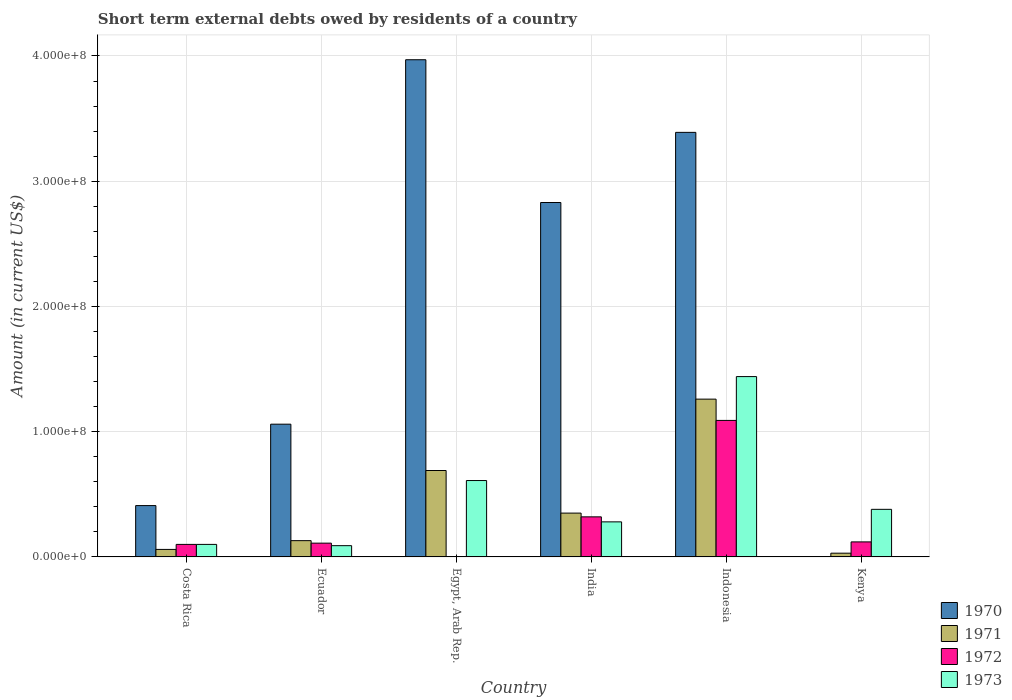Are the number of bars on each tick of the X-axis equal?
Your response must be concise. No. How many bars are there on the 4th tick from the right?
Offer a terse response. 3. What is the label of the 6th group of bars from the left?
Provide a short and direct response. Kenya. In how many cases, is the number of bars for a given country not equal to the number of legend labels?
Give a very brief answer. 2. What is the amount of short-term external debts owed by residents in 1970 in Costa Rica?
Provide a succinct answer. 4.10e+07. Across all countries, what is the maximum amount of short-term external debts owed by residents in 1970?
Provide a short and direct response. 3.97e+08. What is the total amount of short-term external debts owed by residents in 1971 in the graph?
Give a very brief answer. 2.52e+08. What is the difference between the amount of short-term external debts owed by residents in 1971 in Ecuador and that in Egypt, Arab Rep.?
Provide a succinct answer. -5.60e+07. What is the difference between the amount of short-term external debts owed by residents in 1972 in Costa Rica and the amount of short-term external debts owed by residents in 1973 in India?
Your answer should be very brief. -1.80e+07. What is the average amount of short-term external debts owed by residents in 1973 per country?
Your answer should be compact. 4.83e+07. What is the difference between the amount of short-term external debts owed by residents of/in 1970 and amount of short-term external debts owed by residents of/in 1972 in India?
Offer a terse response. 2.51e+08. What is the ratio of the amount of short-term external debts owed by residents in 1972 in Ecuador to that in India?
Your answer should be very brief. 0.34. What is the difference between the highest and the second highest amount of short-term external debts owed by residents in 1970?
Ensure brevity in your answer.  1.14e+08. What is the difference between the highest and the lowest amount of short-term external debts owed by residents in 1972?
Provide a succinct answer. 1.09e+08. Is it the case that in every country, the sum of the amount of short-term external debts owed by residents in 1973 and amount of short-term external debts owed by residents in 1972 is greater than the sum of amount of short-term external debts owed by residents in 1970 and amount of short-term external debts owed by residents in 1971?
Offer a very short reply. No. Is it the case that in every country, the sum of the amount of short-term external debts owed by residents in 1971 and amount of short-term external debts owed by residents in 1970 is greater than the amount of short-term external debts owed by residents in 1972?
Your response must be concise. No. How many bars are there?
Give a very brief answer. 22. Are all the bars in the graph horizontal?
Keep it short and to the point. No. Are the values on the major ticks of Y-axis written in scientific E-notation?
Make the answer very short. Yes. Does the graph contain any zero values?
Your answer should be compact. Yes. Does the graph contain grids?
Provide a short and direct response. Yes. Where does the legend appear in the graph?
Your response must be concise. Bottom right. What is the title of the graph?
Ensure brevity in your answer.  Short term external debts owed by residents of a country. Does "1994" appear as one of the legend labels in the graph?
Offer a very short reply. No. What is the label or title of the Y-axis?
Ensure brevity in your answer.  Amount (in current US$). What is the Amount (in current US$) of 1970 in Costa Rica?
Offer a very short reply. 4.10e+07. What is the Amount (in current US$) in 1973 in Costa Rica?
Offer a terse response. 1.00e+07. What is the Amount (in current US$) in 1970 in Ecuador?
Ensure brevity in your answer.  1.06e+08. What is the Amount (in current US$) of 1971 in Ecuador?
Provide a short and direct response. 1.30e+07. What is the Amount (in current US$) of 1972 in Ecuador?
Provide a short and direct response. 1.10e+07. What is the Amount (in current US$) in 1973 in Ecuador?
Make the answer very short. 9.00e+06. What is the Amount (in current US$) of 1970 in Egypt, Arab Rep.?
Provide a succinct answer. 3.97e+08. What is the Amount (in current US$) of 1971 in Egypt, Arab Rep.?
Offer a terse response. 6.90e+07. What is the Amount (in current US$) of 1973 in Egypt, Arab Rep.?
Provide a short and direct response. 6.10e+07. What is the Amount (in current US$) in 1970 in India?
Provide a short and direct response. 2.83e+08. What is the Amount (in current US$) of 1971 in India?
Offer a terse response. 3.50e+07. What is the Amount (in current US$) in 1972 in India?
Give a very brief answer. 3.20e+07. What is the Amount (in current US$) of 1973 in India?
Keep it short and to the point. 2.80e+07. What is the Amount (in current US$) in 1970 in Indonesia?
Offer a very short reply. 3.39e+08. What is the Amount (in current US$) in 1971 in Indonesia?
Provide a succinct answer. 1.26e+08. What is the Amount (in current US$) of 1972 in Indonesia?
Offer a terse response. 1.09e+08. What is the Amount (in current US$) of 1973 in Indonesia?
Provide a short and direct response. 1.44e+08. What is the Amount (in current US$) of 1971 in Kenya?
Keep it short and to the point. 3.00e+06. What is the Amount (in current US$) in 1972 in Kenya?
Give a very brief answer. 1.20e+07. What is the Amount (in current US$) of 1973 in Kenya?
Offer a terse response. 3.80e+07. Across all countries, what is the maximum Amount (in current US$) in 1970?
Provide a short and direct response. 3.97e+08. Across all countries, what is the maximum Amount (in current US$) of 1971?
Give a very brief answer. 1.26e+08. Across all countries, what is the maximum Amount (in current US$) in 1972?
Make the answer very short. 1.09e+08. Across all countries, what is the maximum Amount (in current US$) in 1973?
Your answer should be compact. 1.44e+08. Across all countries, what is the minimum Amount (in current US$) of 1971?
Your answer should be very brief. 3.00e+06. Across all countries, what is the minimum Amount (in current US$) in 1973?
Make the answer very short. 9.00e+06. What is the total Amount (in current US$) in 1970 in the graph?
Give a very brief answer. 1.17e+09. What is the total Amount (in current US$) of 1971 in the graph?
Keep it short and to the point. 2.52e+08. What is the total Amount (in current US$) in 1972 in the graph?
Make the answer very short. 1.74e+08. What is the total Amount (in current US$) in 1973 in the graph?
Provide a short and direct response. 2.90e+08. What is the difference between the Amount (in current US$) in 1970 in Costa Rica and that in Ecuador?
Give a very brief answer. -6.50e+07. What is the difference between the Amount (in current US$) in 1971 in Costa Rica and that in Ecuador?
Ensure brevity in your answer.  -7.00e+06. What is the difference between the Amount (in current US$) of 1973 in Costa Rica and that in Ecuador?
Your answer should be compact. 1.00e+06. What is the difference between the Amount (in current US$) in 1970 in Costa Rica and that in Egypt, Arab Rep.?
Provide a succinct answer. -3.56e+08. What is the difference between the Amount (in current US$) of 1971 in Costa Rica and that in Egypt, Arab Rep.?
Your response must be concise. -6.30e+07. What is the difference between the Amount (in current US$) in 1973 in Costa Rica and that in Egypt, Arab Rep.?
Provide a short and direct response. -5.10e+07. What is the difference between the Amount (in current US$) in 1970 in Costa Rica and that in India?
Offer a terse response. -2.42e+08. What is the difference between the Amount (in current US$) in 1971 in Costa Rica and that in India?
Give a very brief answer. -2.90e+07. What is the difference between the Amount (in current US$) of 1972 in Costa Rica and that in India?
Your answer should be compact. -2.20e+07. What is the difference between the Amount (in current US$) of 1973 in Costa Rica and that in India?
Your response must be concise. -1.80e+07. What is the difference between the Amount (in current US$) of 1970 in Costa Rica and that in Indonesia?
Your response must be concise. -2.98e+08. What is the difference between the Amount (in current US$) of 1971 in Costa Rica and that in Indonesia?
Offer a terse response. -1.20e+08. What is the difference between the Amount (in current US$) of 1972 in Costa Rica and that in Indonesia?
Your answer should be compact. -9.90e+07. What is the difference between the Amount (in current US$) in 1973 in Costa Rica and that in Indonesia?
Your answer should be compact. -1.34e+08. What is the difference between the Amount (in current US$) of 1971 in Costa Rica and that in Kenya?
Your response must be concise. 3.00e+06. What is the difference between the Amount (in current US$) in 1973 in Costa Rica and that in Kenya?
Make the answer very short. -2.80e+07. What is the difference between the Amount (in current US$) in 1970 in Ecuador and that in Egypt, Arab Rep.?
Provide a succinct answer. -2.91e+08. What is the difference between the Amount (in current US$) in 1971 in Ecuador and that in Egypt, Arab Rep.?
Make the answer very short. -5.60e+07. What is the difference between the Amount (in current US$) of 1973 in Ecuador and that in Egypt, Arab Rep.?
Keep it short and to the point. -5.20e+07. What is the difference between the Amount (in current US$) of 1970 in Ecuador and that in India?
Make the answer very short. -1.77e+08. What is the difference between the Amount (in current US$) of 1971 in Ecuador and that in India?
Ensure brevity in your answer.  -2.20e+07. What is the difference between the Amount (in current US$) in 1972 in Ecuador and that in India?
Your response must be concise. -2.10e+07. What is the difference between the Amount (in current US$) in 1973 in Ecuador and that in India?
Your response must be concise. -1.90e+07. What is the difference between the Amount (in current US$) in 1970 in Ecuador and that in Indonesia?
Offer a very short reply. -2.33e+08. What is the difference between the Amount (in current US$) in 1971 in Ecuador and that in Indonesia?
Your response must be concise. -1.13e+08. What is the difference between the Amount (in current US$) of 1972 in Ecuador and that in Indonesia?
Give a very brief answer. -9.80e+07. What is the difference between the Amount (in current US$) in 1973 in Ecuador and that in Indonesia?
Provide a short and direct response. -1.35e+08. What is the difference between the Amount (in current US$) in 1973 in Ecuador and that in Kenya?
Provide a short and direct response. -2.90e+07. What is the difference between the Amount (in current US$) of 1970 in Egypt, Arab Rep. and that in India?
Give a very brief answer. 1.14e+08. What is the difference between the Amount (in current US$) in 1971 in Egypt, Arab Rep. and that in India?
Keep it short and to the point. 3.40e+07. What is the difference between the Amount (in current US$) of 1973 in Egypt, Arab Rep. and that in India?
Provide a succinct answer. 3.30e+07. What is the difference between the Amount (in current US$) in 1970 in Egypt, Arab Rep. and that in Indonesia?
Your answer should be very brief. 5.80e+07. What is the difference between the Amount (in current US$) of 1971 in Egypt, Arab Rep. and that in Indonesia?
Ensure brevity in your answer.  -5.70e+07. What is the difference between the Amount (in current US$) of 1973 in Egypt, Arab Rep. and that in Indonesia?
Your answer should be very brief. -8.30e+07. What is the difference between the Amount (in current US$) of 1971 in Egypt, Arab Rep. and that in Kenya?
Ensure brevity in your answer.  6.60e+07. What is the difference between the Amount (in current US$) of 1973 in Egypt, Arab Rep. and that in Kenya?
Ensure brevity in your answer.  2.30e+07. What is the difference between the Amount (in current US$) in 1970 in India and that in Indonesia?
Give a very brief answer. -5.60e+07. What is the difference between the Amount (in current US$) in 1971 in India and that in Indonesia?
Make the answer very short. -9.10e+07. What is the difference between the Amount (in current US$) of 1972 in India and that in Indonesia?
Ensure brevity in your answer.  -7.70e+07. What is the difference between the Amount (in current US$) in 1973 in India and that in Indonesia?
Your answer should be compact. -1.16e+08. What is the difference between the Amount (in current US$) of 1971 in India and that in Kenya?
Your answer should be compact. 3.20e+07. What is the difference between the Amount (in current US$) of 1973 in India and that in Kenya?
Ensure brevity in your answer.  -1.00e+07. What is the difference between the Amount (in current US$) of 1971 in Indonesia and that in Kenya?
Your answer should be very brief. 1.23e+08. What is the difference between the Amount (in current US$) in 1972 in Indonesia and that in Kenya?
Provide a succinct answer. 9.70e+07. What is the difference between the Amount (in current US$) of 1973 in Indonesia and that in Kenya?
Your response must be concise. 1.06e+08. What is the difference between the Amount (in current US$) of 1970 in Costa Rica and the Amount (in current US$) of 1971 in Ecuador?
Your response must be concise. 2.80e+07. What is the difference between the Amount (in current US$) of 1970 in Costa Rica and the Amount (in current US$) of 1972 in Ecuador?
Give a very brief answer. 3.00e+07. What is the difference between the Amount (in current US$) in 1970 in Costa Rica and the Amount (in current US$) in 1973 in Ecuador?
Your answer should be very brief. 3.20e+07. What is the difference between the Amount (in current US$) in 1971 in Costa Rica and the Amount (in current US$) in 1972 in Ecuador?
Offer a terse response. -5.00e+06. What is the difference between the Amount (in current US$) of 1972 in Costa Rica and the Amount (in current US$) of 1973 in Ecuador?
Give a very brief answer. 1.00e+06. What is the difference between the Amount (in current US$) of 1970 in Costa Rica and the Amount (in current US$) of 1971 in Egypt, Arab Rep.?
Your response must be concise. -2.80e+07. What is the difference between the Amount (in current US$) in 1970 in Costa Rica and the Amount (in current US$) in 1973 in Egypt, Arab Rep.?
Ensure brevity in your answer.  -2.00e+07. What is the difference between the Amount (in current US$) in 1971 in Costa Rica and the Amount (in current US$) in 1973 in Egypt, Arab Rep.?
Keep it short and to the point. -5.50e+07. What is the difference between the Amount (in current US$) of 1972 in Costa Rica and the Amount (in current US$) of 1973 in Egypt, Arab Rep.?
Offer a very short reply. -5.10e+07. What is the difference between the Amount (in current US$) of 1970 in Costa Rica and the Amount (in current US$) of 1971 in India?
Offer a terse response. 6.00e+06. What is the difference between the Amount (in current US$) of 1970 in Costa Rica and the Amount (in current US$) of 1972 in India?
Offer a terse response. 9.00e+06. What is the difference between the Amount (in current US$) of 1970 in Costa Rica and the Amount (in current US$) of 1973 in India?
Provide a short and direct response. 1.30e+07. What is the difference between the Amount (in current US$) of 1971 in Costa Rica and the Amount (in current US$) of 1972 in India?
Give a very brief answer. -2.60e+07. What is the difference between the Amount (in current US$) in 1971 in Costa Rica and the Amount (in current US$) in 1973 in India?
Make the answer very short. -2.20e+07. What is the difference between the Amount (in current US$) in 1972 in Costa Rica and the Amount (in current US$) in 1973 in India?
Offer a terse response. -1.80e+07. What is the difference between the Amount (in current US$) in 1970 in Costa Rica and the Amount (in current US$) in 1971 in Indonesia?
Offer a terse response. -8.50e+07. What is the difference between the Amount (in current US$) of 1970 in Costa Rica and the Amount (in current US$) of 1972 in Indonesia?
Make the answer very short. -6.80e+07. What is the difference between the Amount (in current US$) in 1970 in Costa Rica and the Amount (in current US$) in 1973 in Indonesia?
Your response must be concise. -1.03e+08. What is the difference between the Amount (in current US$) of 1971 in Costa Rica and the Amount (in current US$) of 1972 in Indonesia?
Keep it short and to the point. -1.03e+08. What is the difference between the Amount (in current US$) in 1971 in Costa Rica and the Amount (in current US$) in 1973 in Indonesia?
Ensure brevity in your answer.  -1.38e+08. What is the difference between the Amount (in current US$) in 1972 in Costa Rica and the Amount (in current US$) in 1973 in Indonesia?
Ensure brevity in your answer.  -1.34e+08. What is the difference between the Amount (in current US$) in 1970 in Costa Rica and the Amount (in current US$) in 1971 in Kenya?
Offer a terse response. 3.80e+07. What is the difference between the Amount (in current US$) of 1970 in Costa Rica and the Amount (in current US$) of 1972 in Kenya?
Your answer should be compact. 2.90e+07. What is the difference between the Amount (in current US$) in 1970 in Costa Rica and the Amount (in current US$) in 1973 in Kenya?
Make the answer very short. 3.00e+06. What is the difference between the Amount (in current US$) of 1971 in Costa Rica and the Amount (in current US$) of 1972 in Kenya?
Provide a short and direct response. -6.00e+06. What is the difference between the Amount (in current US$) in 1971 in Costa Rica and the Amount (in current US$) in 1973 in Kenya?
Give a very brief answer. -3.20e+07. What is the difference between the Amount (in current US$) of 1972 in Costa Rica and the Amount (in current US$) of 1973 in Kenya?
Provide a short and direct response. -2.80e+07. What is the difference between the Amount (in current US$) of 1970 in Ecuador and the Amount (in current US$) of 1971 in Egypt, Arab Rep.?
Keep it short and to the point. 3.70e+07. What is the difference between the Amount (in current US$) in 1970 in Ecuador and the Amount (in current US$) in 1973 in Egypt, Arab Rep.?
Your answer should be compact. 4.50e+07. What is the difference between the Amount (in current US$) in 1971 in Ecuador and the Amount (in current US$) in 1973 in Egypt, Arab Rep.?
Make the answer very short. -4.80e+07. What is the difference between the Amount (in current US$) of 1972 in Ecuador and the Amount (in current US$) of 1973 in Egypt, Arab Rep.?
Your answer should be very brief. -5.00e+07. What is the difference between the Amount (in current US$) of 1970 in Ecuador and the Amount (in current US$) of 1971 in India?
Provide a short and direct response. 7.10e+07. What is the difference between the Amount (in current US$) in 1970 in Ecuador and the Amount (in current US$) in 1972 in India?
Make the answer very short. 7.40e+07. What is the difference between the Amount (in current US$) of 1970 in Ecuador and the Amount (in current US$) of 1973 in India?
Offer a very short reply. 7.80e+07. What is the difference between the Amount (in current US$) in 1971 in Ecuador and the Amount (in current US$) in 1972 in India?
Make the answer very short. -1.90e+07. What is the difference between the Amount (in current US$) in 1971 in Ecuador and the Amount (in current US$) in 1973 in India?
Your response must be concise. -1.50e+07. What is the difference between the Amount (in current US$) of 1972 in Ecuador and the Amount (in current US$) of 1973 in India?
Provide a succinct answer. -1.70e+07. What is the difference between the Amount (in current US$) of 1970 in Ecuador and the Amount (in current US$) of 1971 in Indonesia?
Offer a terse response. -2.00e+07. What is the difference between the Amount (in current US$) in 1970 in Ecuador and the Amount (in current US$) in 1972 in Indonesia?
Provide a short and direct response. -3.00e+06. What is the difference between the Amount (in current US$) in 1970 in Ecuador and the Amount (in current US$) in 1973 in Indonesia?
Provide a succinct answer. -3.80e+07. What is the difference between the Amount (in current US$) in 1971 in Ecuador and the Amount (in current US$) in 1972 in Indonesia?
Offer a very short reply. -9.60e+07. What is the difference between the Amount (in current US$) of 1971 in Ecuador and the Amount (in current US$) of 1973 in Indonesia?
Offer a very short reply. -1.31e+08. What is the difference between the Amount (in current US$) of 1972 in Ecuador and the Amount (in current US$) of 1973 in Indonesia?
Offer a terse response. -1.33e+08. What is the difference between the Amount (in current US$) in 1970 in Ecuador and the Amount (in current US$) in 1971 in Kenya?
Keep it short and to the point. 1.03e+08. What is the difference between the Amount (in current US$) of 1970 in Ecuador and the Amount (in current US$) of 1972 in Kenya?
Your response must be concise. 9.40e+07. What is the difference between the Amount (in current US$) of 1970 in Ecuador and the Amount (in current US$) of 1973 in Kenya?
Make the answer very short. 6.80e+07. What is the difference between the Amount (in current US$) in 1971 in Ecuador and the Amount (in current US$) in 1972 in Kenya?
Your answer should be very brief. 1.00e+06. What is the difference between the Amount (in current US$) of 1971 in Ecuador and the Amount (in current US$) of 1973 in Kenya?
Provide a succinct answer. -2.50e+07. What is the difference between the Amount (in current US$) in 1972 in Ecuador and the Amount (in current US$) in 1973 in Kenya?
Your answer should be very brief. -2.70e+07. What is the difference between the Amount (in current US$) in 1970 in Egypt, Arab Rep. and the Amount (in current US$) in 1971 in India?
Ensure brevity in your answer.  3.62e+08. What is the difference between the Amount (in current US$) of 1970 in Egypt, Arab Rep. and the Amount (in current US$) of 1972 in India?
Make the answer very short. 3.65e+08. What is the difference between the Amount (in current US$) in 1970 in Egypt, Arab Rep. and the Amount (in current US$) in 1973 in India?
Ensure brevity in your answer.  3.69e+08. What is the difference between the Amount (in current US$) of 1971 in Egypt, Arab Rep. and the Amount (in current US$) of 1972 in India?
Ensure brevity in your answer.  3.70e+07. What is the difference between the Amount (in current US$) of 1971 in Egypt, Arab Rep. and the Amount (in current US$) of 1973 in India?
Offer a very short reply. 4.10e+07. What is the difference between the Amount (in current US$) of 1970 in Egypt, Arab Rep. and the Amount (in current US$) of 1971 in Indonesia?
Offer a very short reply. 2.71e+08. What is the difference between the Amount (in current US$) of 1970 in Egypt, Arab Rep. and the Amount (in current US$) of 1972 in Indonesia?
Provide a succinct answer. 2.88e+08. What is the difference between the Amount (in current US$) in 1970 in Egypt, Arab Rep. and the Amount (in current US$) in 1973 in Indonesia?
Your response must be concise. 2.53e+08. What is the difference between the Amount (in current US$) in 1971 in Egypt, Arab Rep. and the Amount (in current US$) in 1972 in Indonesia?
Give a very brief answer. -4.00e+07. What is the difference between the Amount (in current US$) of 1971 in Egypt, Arab Rep. and the Amount (in current US$) of 1973 in Indonesia?
Your answer should be compact. -7.50e+07. What is the difference between the Amount (in current US$) of 1970 in Egypt, Arab Rep. and the Amount (in current US$) of 1971 in Kenya?
Give a very brief answer. 3.94e+08. What is the difference between the Amount (in current US$) of 1970 in Egypt, Arab Rep. and the Amount (in current US$) of 1972 in Kenya?
Offer a very short reply. 3.85e+08. What is the difference between the Amount (in current US$) of 1970 in Egypt, Arab Rep. and the Amount (in current US$) of 1973 in Kenya?
Provide a short and direct response. 3.59e+08. What is the difference between the Amount (in current US$) of 1971 in Egypt, Arab Rep. and the Amount (in current US$) of 1972 in Kenya?
Provide a short and direct response. 5.70e+07. What is the difference between the Amount (in current US$) in 1971 in Egypt, Arab Rep. and the Amount (in current US$) in 1973 in Kenya?
Ensure brevity in your answer.  3.10e+07. What is the difference between the Amount (in current US$) in 1970 in India and the Amount (in current US$) in 1971 in Indonesia?
Your answer should be very brief. 1.57e+08. What is the difference between the Amount (in current US$) in 1970 in India and the Amount (in current US$) in 1972 in Indonesia?
Your answer should be very brief. 1.74e+08. What is the difference between the Amount (in current US$) of 1970 in India and the Amount (in current US$) of 1973 in Indonesia?
Your answer should be very brief. 1.39e+08. What is the difference between the Amount (in current US$) of 1971 in India and the Amount (in current US$) of 1972 in Indonesia?
Give a very brief answer. -7.40e+07. What is the difference between the Amount (in current US$) in 1971 in India and the Amount (in current US$) in 1973 in Indonesia?
Ensure brevity in your answer.  -1.09e+08. What is the difference between the Amount (in current US$) in 1972 in India and the Amount (in current US$) in 1973 in Indonesia?
Your answer should be compact. -1.12e+08. What is the difference between the Amount (in current US$) in 1970 in India and the Amount (in current US$) in 1971 in Kenya?
Offer a very short reply. 2.80e+08. What is the difference between the Amount (in current US$) of 1970 in India and the Amount (in current US$) of 1972 in Kenya?
Make the answer very short. 2.71e+08. What is the difference between the Amount (in current US$) of 1970 in India and the Amount (in current US$) of 1973 in Kenya?
Make the answer very short. 2.45e+08. What is the difference between the Amount (in current US$) of 1971 in India and the Amount (in current US$) of 1972 in Kenya?
Provide a succinct answer. 2.30e+07. What is the difference between the Amount (in current US$) of 1971 in India and the Amount (in current US$) of 1973 in Kenya?
Offer a very short reply. -3.00e+06. What is the difference between the Amount (in current US$) in 1972 in India and the Amount (in current US$) in 1973 in Kenya?
Provide a succinct answer. -6.00e+06. What is the difference between the Amount (in current US$) in 1970 in Indonesia and the Amount (in current US$) in 1971 in Kenya?
Provide a short and direct response. 3.36e+08. What is the difference between the Amount (in current US$) of 1970 in Indonesia and the Amount (in current US$) of 1972 in Kenya?
Keep it short and to the point. 3.27e+08. What is the difference between the Amount (in current US$) in 1970 in Indonesia and the Amount (in current US$) in 1973 in Kenya?
Ensure brevity in your answer.  3.01e+08. What is the difference between the Amount (in current US$) in 1971 in Indonesia and the Amount (in current US$) in 1972 in Kenya?
Make the answer very short. 1.14e+08. What is the difference between the Amount (in current US$) in 1971 in Indonesia and the Amount (in current US$) in 1973 in Kenya?
Ensure brevity in your answer.  8.80e+07. What is the difference between the Amount (in current US$) of 1972 in Indonesia and the Amount (in current US$) of 1973 in Kenya?
Ensure brevity in your answer.  7.10e+07. What is the average Amount (in current US$) of 1970 per country?
Keep it short and to the point. 1.94e+08. What is the average Amount (in current US$) in 1971 per country?
Keep it short and to the point. 4.20e+07. What is the average Amount (in current US$) in 1972 per country?
Your answer should be very brief. 2.90e+07. What is the average Amount (in current US$) in 1973 per country?
Your answer should be compact. 4.83e+07. What is the difference between the Amount (in current US$) of 1970 and Amount (in current US$) of 1971 in Costa Rica?
Make the answer very short. 3.50e+07. What is the difference between the Amount (in current US$) of 1970 and Amount (in current US$) of 1972 in Costa Rica?
Ensure brevity in your answer.  3.10e+07. What is the difference between the Amount (in current US$) in 1970 and Amount (in current US$) in 1973 in Costa Rica?
Offer a terse response. 3.10e+07. What is the difference between the Amount (in current US$) of 1972 and Amount (in current US$) of 1973 in Costa Rica?
Make the answer very short. 0. What is the difference between the Amount (in current US$) in 1970 and Amount (in current US$) in 1971 in Ecuador?
Offer a very short reply. 9.30e+07. What is the difference between the Amount (in current US$) of 1970 and Amount (in current US$) of 1972 in Ecuador?
Ensure brevity in your answer.  9.50e+07. What is the difference between the Amount (in current US$) of 1970 and Amount (in current US$) of 1973 in Ecuador?
Ensure brevity in your answer.  9.70e+07. What is the difference between the Amount (in current US$) in 1971 and Amount (in current US$) in 1972 in Ecuador?
Keep it short and to the point. 2.00e+06. What is the difference between the Amount (in current US$) of 1971 and Amount (in current US$) of 1973 in Ecuador?
Provide a short and direct response. 4.00e+06. What is the difference between the Amount (in current US$) in 1970 and Amount (in current US$) in 1971 in Egypt, Arab Rep.?
Make the answer very short. 3.28e+08. What is the difference between the Amount (in current US$) of 1970 and Amount (in current US$) of 1973 in Egypt, Arab Rep.?
Offer a terse response. 3.36e+08. What is the difference between the Amount (in current US$) in 1971 and Amount (in current US$) in 1973 in Egypt, Arab Rep.?
Your answer should be very brief. 8.00e+06. What is the difference between the Amount (in current US$) in 1970 and Amount (in current US$) in 1971 in India?
Your answer should be compact. 2.48e+08. What is the difference between the Amount (in current US$) of 1970 and Amount (in current US$) of 1972 in India?
Give a very brief answer. 2.51e+08. What is the difference between the Amount (in current US$) in 1970 and Amount (in current US$) in 1973 in India?
Offer a terse response. 2.55e+08. What is the difference between the Amount (in current US$) in 1971 and Amount (in current US$) in 1972 in India?
Your answer should be very brief. 3.00e+06. What is the difference between the Amount (in current US$) in 1971 and Amount (in current US$) in 1973 in India?
Make the answer very short. 7.00e+06. What is the difference between the Amount (in current US$) of 1970 and Amount (in current US$) of 1971 in Indonesia?
Ensure brevity in your answer.  2.13e+08. What is the difference between the Amount (in current US$) of 1970 and Amount (in current US$) of 1972 in Indonesia?
Your answer should be compact. 2.30e+08. What is the difference between the Amount (in current US$) of 1970 and Amount (in current US$) of 1973 in Indonesia?
Offer a very short reply. 1.95e+08. What is the difference between the Amount (in current US$) of 1971 and Amount (in current US$) of 1972 in Indonesia?
Provide a short and direct response. 1.70e+07. What is the difference between the Amount (in current US$) of 1971 and Amount (in current US$) of 1973 in Indonesia?
Make the answer very short. -1.80e+07. What is the difference between the Amount (in current US$) of 1972 and Amount (in current US$) of 1973 in Indonesia?
Provide a succinct answer. -3.50e+07. What is the difference between the Amount (in current US$) in 1971 and Amount (in current US$) in 1972 in Kenya?
Provide a succinct answer. -9.00e+06. What is the difference between the Amount (in current US$) in 1971 and Amount (in current US$) in 1973 in Kenya?
Keep it short and to the point. -3.50e+07. What is the difference between the Amount (in current US$) in 1972 and Amount (in current US$) in 1973 in Kenya?
Your answer should be very brief. -2.60e+07. What is the ratio of the Amount (in current US$) of 1970 in Costa Rica to that in Ecuador?
Provide a short and direct response. 0.39. What is the ratio of the Amount (in current US$) of 1971 in Costa Rica to that in Ecuador?
Provide a succinct answer. 0.46. What is the ratio of the Amount (in current US$) in 1972 in Costa Rica to that in Ecuador?
Your answer should be very brief. 0.91. What is the ratio of the Amount (in current US$) of 1973 in Costa Rica to that in Ecuador?
Ensure brevity in your answer.  1.11. What is the ratio of the Amount (in current US$) of 1970 in Costa Rica to that in Egypt, Arab Rep.?
Your answer should be compact. 0.1. What is the ratio of the Amount (in current US$) in 1971 in Costa Rica to that in Egypt, Arab Rep.?
Your response must be concise. 0.09. What is the ratio of the Amount (in current US$) of 1973 in Costa Rica to that in Egypt, Arab Rep.?
Ensure brevity in your answer.  0.16. What is the ratio of the Amount (in current US$) in 1970 in Costa Rica to that in India?
Offer a terse response. 0.14. What is the ratio of the Amount (in current US$) of 1971 in Costa Rica to that in India?
Your answer should be very brief. 0.17. What is the ratio of the Amount (in current US$) of 1972 in Costa Rica to that in India?
Your answer should be very brief. 0.31. What is the ratio of the Amount (in current US$) of 1973 in Costa Rica to that in India?
Ensure brevity in your answer.  0.36. What is the ratio of the Amount (in current US$) in 1970 in Costa Rica to that in Indonesia?
Provide a succinct answer. 0.12. What is the ratio of the Amount (in current US$) in 1971 in Costa Rica to that in Indonesia?
Offer a terse response. 0.05. What is the ratio of the Amount (in current US$) of 1972 in Costa Rica to that in Indonesia?
Your response must be concise. 0.09. What is the ratio of the Amount (in current US$) of 1973 in Costa Rica to that in Indonesia?
Provide a succinct answer. 0.07. What is the ratio of the Amount (in current US$) of 1972 in Costa Rica to that in Kenya?
Your answer should be compact. 0.83. What is the ratio of the Amount (in current US$) of 1973 in Costa Rica to that in Kenya?
Your answer should be very brief. 0.26. What is the ratio of the Amount (in current US$) in 1970 in Ecuador to that in Egypt, Arab Rep.?
Provide a short and direct response. 0.27. What is the ratio of the Amount (in current US$) in 1971 in Ecuador to that in Egypt, Arab Rep.?
Your answer should be compact. 0.19. What is the ratio of the Amount (in current US$) of 1973 in Ecuador to that in Egypt, Arab Rep.?
Make the answer very short. 0.15. What is the ratio of the Amount (in current US$) of 1970 in Ecuador to that in India?
Give a very brief answer. 0.37. What is the ratio of the Amount (in current US$) of 1971 in Ecuador to that in India?
Offer a very short reply. 0.37. What is the ratio of the Amount (in current US$) of 1972 in Ecuador to that in India?
Provide a short and direct response. 0.34. What is the ratio of the Amount (in current US$) of 1973 in Ecuador to that in India?
Your answer should be very brief. 0.32. What is the ratio of the Amount (in current US$) of 1970 in Ecuador to that in Indonesia?
Your response must be concise. 0.31. What is the ratio of the Amount (in current US$) of 1971 in Ecuador to that in Indonesia?
Keep it short and to the point. 0.1. What is the ratio of the Amount (in current US$) in 1972 in Ecuador to that in Indonesia?
Provide a succinct answer. 0.1. What is the ratio of the Amount (in current US$) in 1973 in Ecuador to that in Indonesia?
Your response must be concise. 0.06. What is the ratio of the Amount (in current US$) in 1971 in Ecuador to that in Kenya?
Your answer should be very brief. 4.33. What is the ratio of the Amount (in current US$) of 1973 in Ecuador to that in Kenya?
Give a very brief answer. 0.24. What is the ratio of the Amount (in current US$) in 1970 in Egypt, Arab Rep. to that in India?
Provide a succinct answer. 1.4. What is the ratio of the Amount (in current US$) in 1971 in Egypt, Arab Rep. to that in India?
Offer a very short reply. 1.97. What is the ratio of the Amount (in current US$) of 1973 in Egypt, Arab Rep. to that in India?
Offer a terse response. 2.18. What is the ratio of the Amount (in current US$) of 1970 in Egypt, Arab Rep. to that in Indonesia?
Your response must be concise. 1.17. What is the ratio of the Amount (in current US$) of 1971 in Egypt, Arab Rep. to that in Indonesia?
Provide a succinct answer. 0.55. What is the ratio of the Amount (in current US$) in 1973 in Egypt, Arab Rep. to that in Indonesia?
Give a very brief answer. 0.42. What is the ratio of the Amount (in current US$) in 1973 in Egypt, Arab Rep. to that in Kenya?
Provide a succinct answer. 1.61. What is the ratio of the Amount (in current US$) of 1970 in India to that in Indonesia?
Your answer should be compact. 0.83. What is the ratio of the Amount (in current US$) in 1971 in India to that in Indonesia?
Offer a terse response. 0.28. What is the ratio of the Amount (in current US$) in 1972 in India to that in Indonesia?
Your answer should be compact. 0.29. What is the ratio of the Amount (in current US$) in 1973 in India to that in Indonesia?
Keep it short and to the point. 0.19. What is the ratio of the Amount (in current US$) in 1971 in India to that in Kenya?
Provide a succinct answer. 11.67. What is the ratio of the Amount (in current US$) of 1972 in India to that in Kenya?
Your answer should be very brief. 2.67. What is the ratio of the Amount (in current US$) in 1973 in India to that in Kenya?
Your response must be concise. 0.74. What is the ratio of the Amount (in current US$) of 1972 in Indonesia to that in Kenya?
Offer a terse response. 9.08. What is the ratio of the Amount (in current US$) of 1973 in Indonesia to that in Kenya?
Give a very brief answer. 3.79. What is the difference between the highest and the second highest Amount (in current US$) in 1970?
Ensure brevity in your answer.  5.80e+07. What is the difference between the highest and the second highest Amount (in current US$) in 1971?
Provide a succinct answer. 5.70e+07. What is the difference between the highest and the second highest Amount (in current US$) in 1972?
Provide a succinct answer. 7.70e+07. What is the difference between the highest and the second highest Amount (in current US$) in 1973?
Your response must be concise. 8.30e+07. What is the difference between the highest and the lowest Amount (in current US$) of 1970?
Offer a very short reply. 3.97e+08. What is the difference between the highest and the lowest Amount (in current US$) in 1971?
Make the answer very short. 1.23e+08. What is the difference between the highest and the lowest Amount (in current US$) in 1972?
Give a very brief answer. 1.09e+08. What is the difference between the highest and the lowest Amount (in current US$) of 1973?
Ensure brevity in your answer.  1.35e+08. 